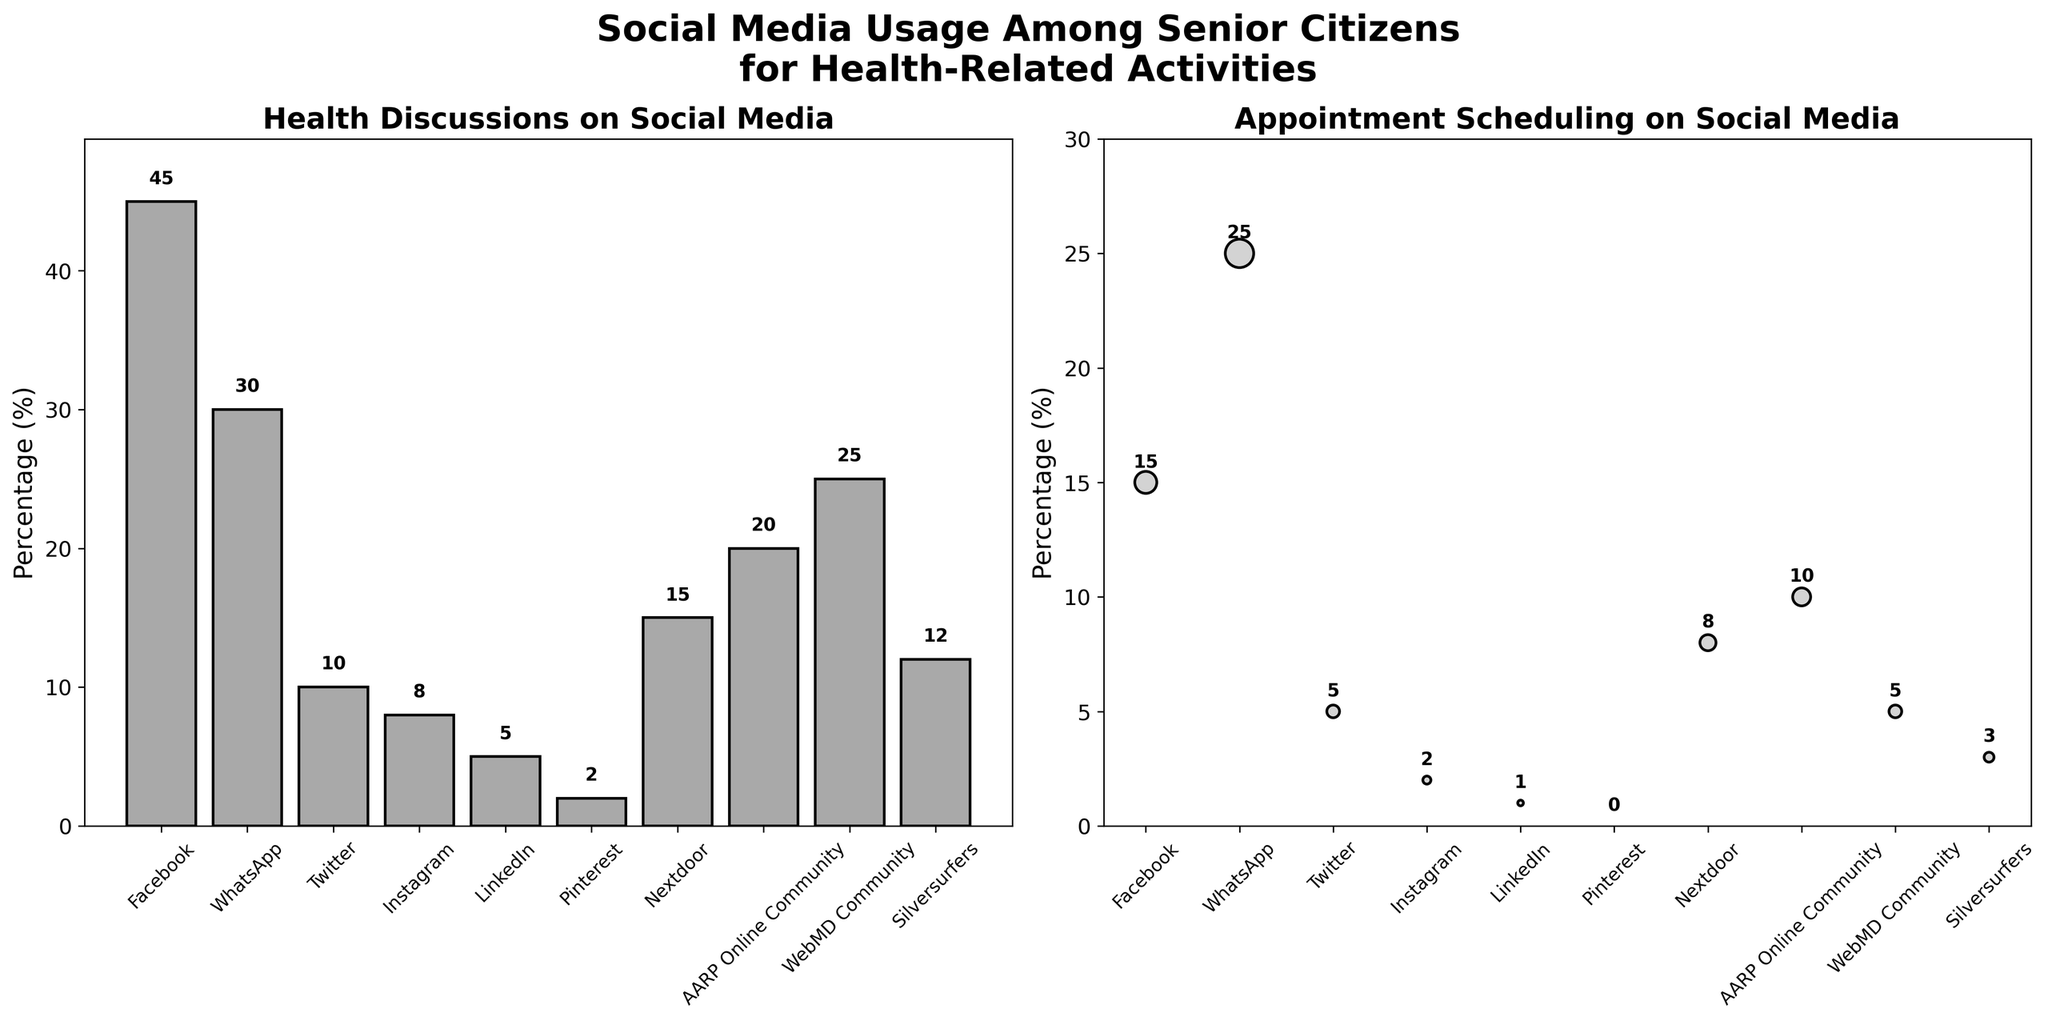What's the main visual feature of the two subplots? The main feature of the first subplot is a bar chart showing percentages of health discussions by platform, and the second subplot is a scatter plot showing percentages of appointment scheduling, characterized by different circle sizes.
Answer: Bar chart and scatter plot What's the highest percentage of health discussions, and which platform does it belong to? The highest bar on the first subplot represents the highest percentage of health discussions. It is 45% on Facebook.
Answer: 45%, Facebook Which platform has the highest percentage for appointment scheduling? The scatter plot shows different circle sizes representing appointment scheduling percentages. The largest circle corresponds to WhatsApp with 25%.
Answer: WhatsApp Comparing Instagram and LinkedIn, which has more users for health discussions and by how much? From the bar chart, Instagram has 8% while LinkedIn has 5%. Therefore, Instagram has 3% more users for health discussions.
Answer: Instagram, 3% Which platform has the lowest percentage for appointment scheduling and what is that percentage? The smallest circle in the scatter plot represents the lowest percentage for appointment scheduling, which is 0% for Pinterest.
Answer: Pinterest, 0% How do the percentages for health discussions and appointment scheduling compare on Nextdoor? By looking at the bar for Nextdoor in the first subplot and the circle in the second, the figures are 15% for health discussions and 8% for appointment scheduling.
Answer: 15%, 8% Calculate the total percentage of senior citizens discussing health on WebMD Community and AARP Online Community. Adding the percentages from the bar chart: WebMD Community (25%) and AARP Online Community (20%) equals 45%.
Answer: 45% Which platform has nearly the same percentage for both health discussions and appointment scheduling? By comparing the two subplots, we see that WebMD Community has 25% for health discussions and 5% for appointment scheduling, while Nextdoor has 15% and 8% respectively.
Answer: WebMD Community, Nextdoor (approx.) For appointment scheduling, which has more: Silversurfers or LinkedIn, and by how much? The scatter plot shows LinkedIn with 1% and Silversurfers with 3%. Silversurfers have 2% more.
Answer: Silversurfers, 2% What percentage of seniors use Facebook for appointment scheduling? The scatter plot shows a circle size with the percentage written near Facebook. It is 15%.
Answer: 15% 